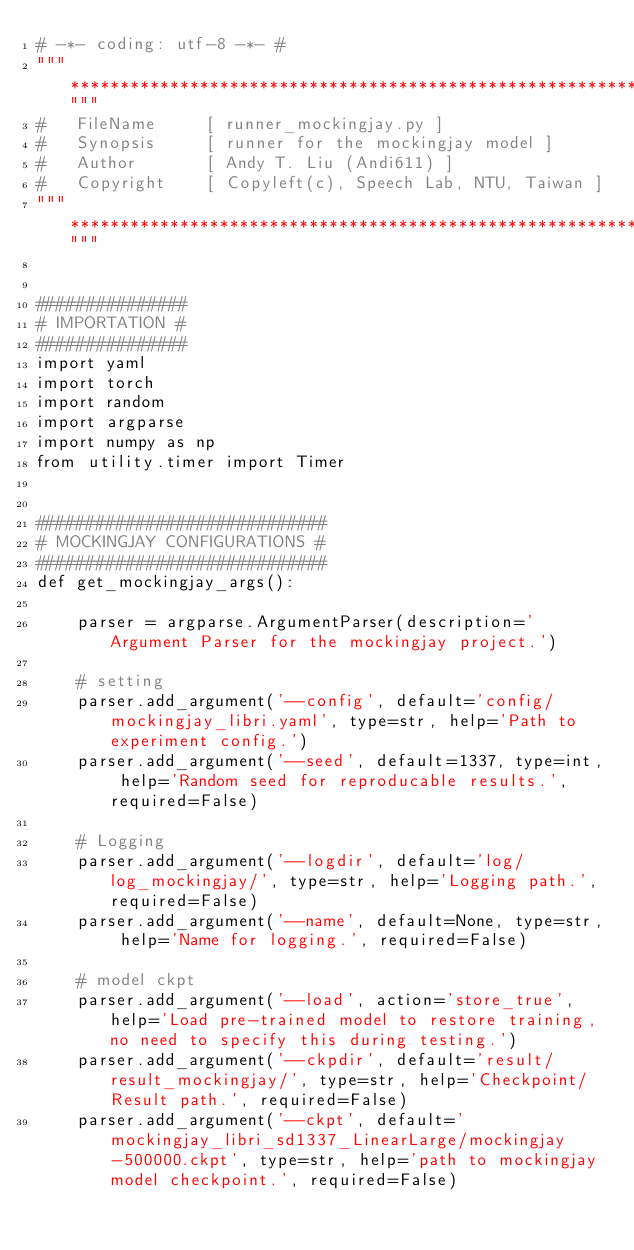<code> <loc_0><loc_0><loc_500><loc_500><_Python_># -*- coding: utf-8 -*- #
"""*********************************************************************************************"""
#   FileName     [ runner_mockingjay.py ]
#   Synopsis     [ runner for the mockingjay model ]
#   Author       [ Andy T. Liu (Andi611) ]
#   Copyright    [ Copyleft(c), Speech Lab, NTU, Taiwan ]
"""*********************************************************************************************"""


###############
# IMPORTATION #
###############
import yaml
import torch
import random
import argparse
import numpy as np
from utility.timer import Timer


#############################
# MOCKINGJAY CONFIGURATIONS #
#############################
def get_mockingjay_args():
    
    parser = argparse.ArgumentParser(description='Argument Parser for the mockingjay project.')
    
    # setting
    parser.add_argument('--config', default='config/mockingjay_libri.yaml', type=str, help='Path to experiment config.')
    parser.add_argument('--seed', default=1337, type=int, help='Random seed for reproducable results.', required=False)

    # Logging
    parser.add_argument('--logdir', default='log/log_mockingjay/', type=str, help='Logging path.', required=False)
    parser.add_argument('--name', default=None, type=str, help='Name for logging.', required=False)

    # model ckpt
    parser.add_argument('--load', action='store_true', help='Load pre-trained model to restore training, no need to specify this during testing.')
    parser.add_argument('--ckpdir', default='result/result_mockingjay/', type=str, help='Checkpoint/Result path.', required=False)
    parser.add_argument('--ckpt', default='mockingjay_libri_sd1337_LinearLarge/mockingjay-500000.ckpt', type=str, help='path to mockingjay model checkpoint.', required=False)</code> 